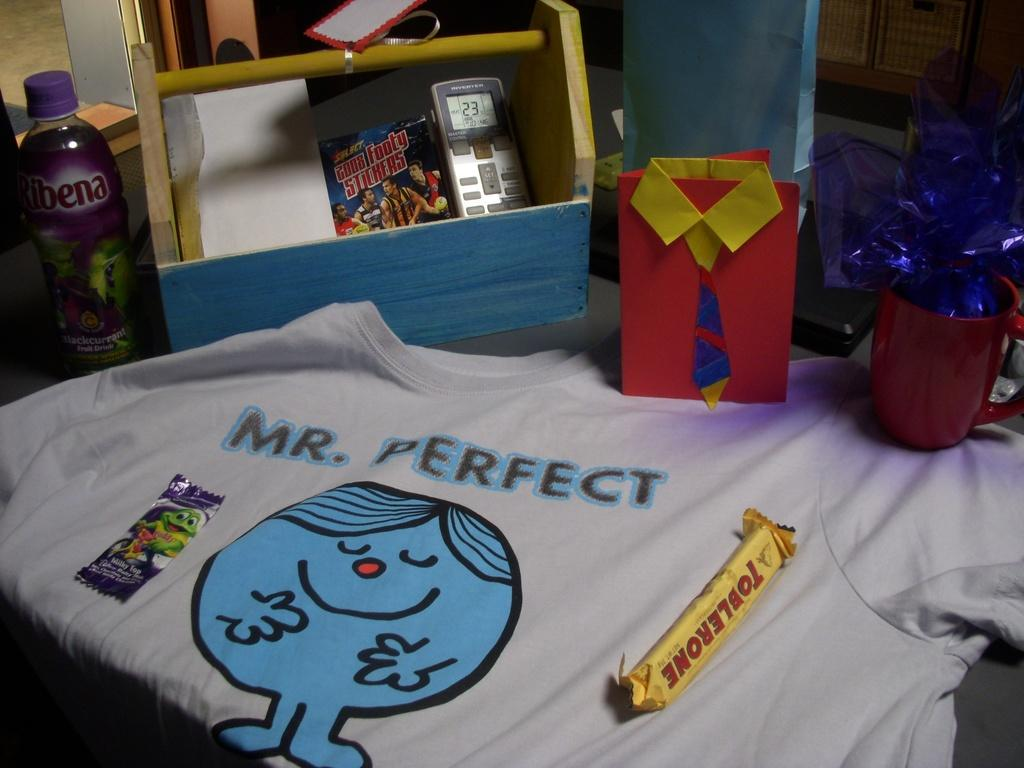<image>
Write a terse but informative summary of the picture. A shirt that says Mr. Perfect on it. 